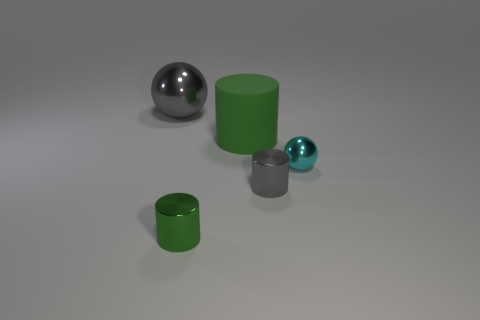Is there any other thing that is the same material as the large green object?
Your answer should be compact. No. How many objects are big rubber cylinders that are right of the small green metallic thing or metal objects that are to the left of the gray shiny cylinder?
Ensure brevity in your answer.  3. There is a small gray shiny object; does it have the same shape as the matte object left of the cyan metal thing?
Keep it short and to the point. Yes. The cyan metal thing on the right side of the gray metallic thing that is to the right of the metallic sphere that is to the left of the green matte cylinder is what shape?
Provide a succinct answer. Sphere. What number of other objects are there of the same material as the small gray thing?
Provide a succinct answer. 3. What number of things are balls that are right of the rubber thing or large brown metal things?
Provide a short and direct response. 1. There is a gray metallic object that is on the right side of the big object left of the tiny green thing; what is its shape?
Your answer should be compact. Cylinder. There is a gray shiny object that is to the right of the tiny green thing; does it have the same shape as the green rubber object?
Offer a very short reply. Yes. There is a ball that is on the left side of the small green shiny object; what is its color?
Your response must be concise. Gray. How many cylinders are large gray shiny objects or tiny red rubber objects?
Offer a very short reply. 0. 